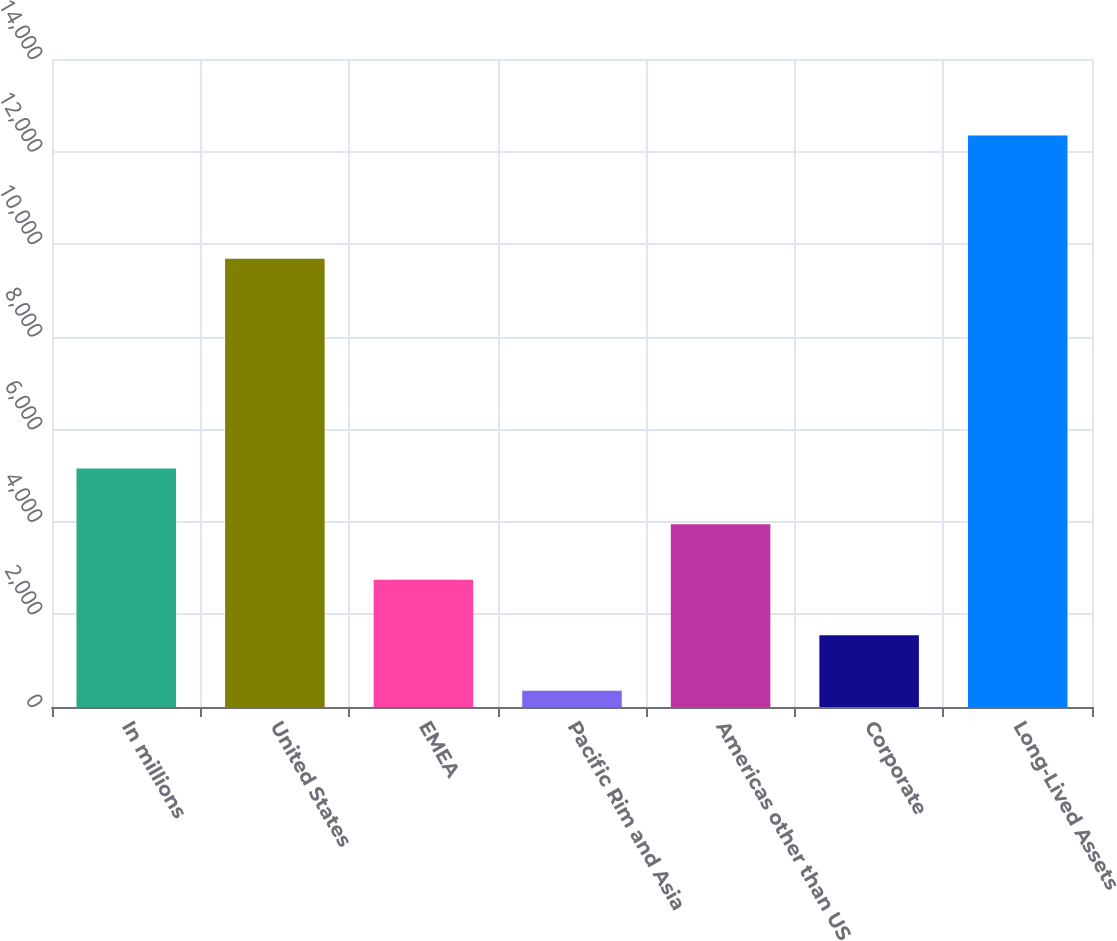<chart> <loc_0><loc_0><loc_500><loc_500><bar_chart><fcel>In millions<fcel>United States<fcel>EMEA<fcel>Pacific Rim and Asia<fcel>Americas other than US<fcel>Corporate<fcel>Long-Lived Assets<nl><fcel>5150.2<fcel>9683<fcel>2751.6<fcel>353<fcel>3950.9<fcel>1552.3<fcel>12346<nl></chart> 